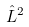<formula> <loc_0><loc_0><loc_500><loc_500>\hat { L } ^ { 2 }</formula> 